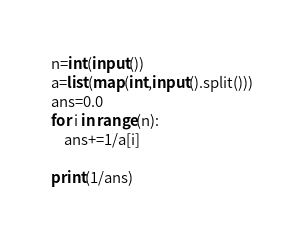<code> <loc_0><loc_0><loc_500><loc_500><_Python_>n=int(input())
a=list(map(int,input().split()))
ans=0.0
for i in range(n):
    ans+=1/a[i]

print(1/ans)</code> 